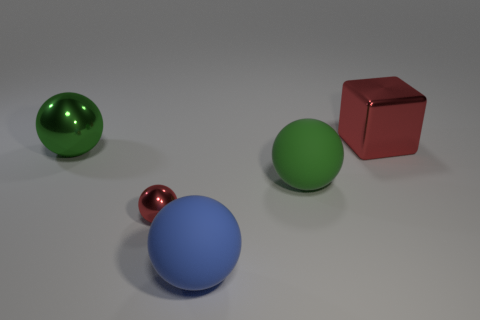Add 4 red shiny cubes. How many objects exist? 9 Subtract all blocks. How many objects are left? 4 Subtract 0 gray cylinders. How many objects are left? 5 Subtract all tiny spheres. Subtract all small red metallic balls. How many objects are left? 3 Add 4 blue matte things. How many blue matte things are left? 5 Add 1 large blocks. How many large blocks exist? 2 